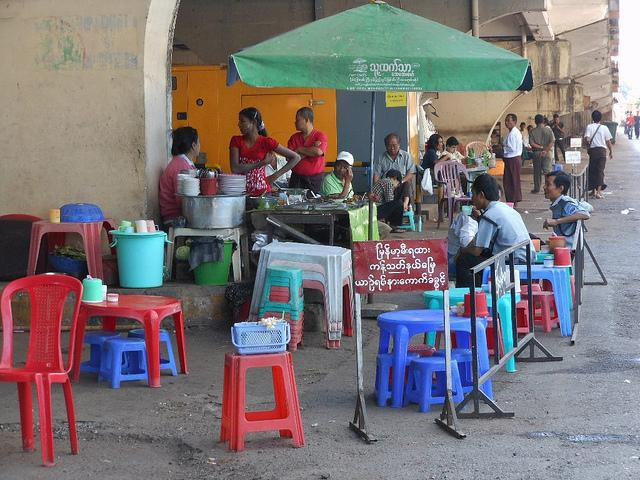What are the colored plastic objects for?

Choices:
A) sitting
B) hold food
C) for sale
D) stacking sitting 